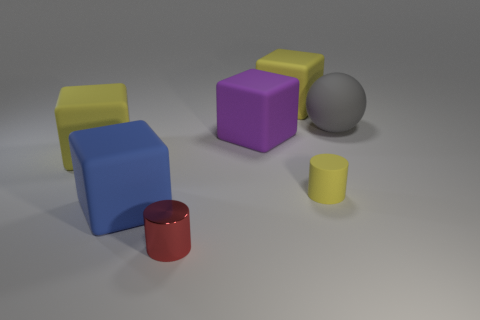Do the rubber cylinder and the matte block on the left side of the blue matte thing have the same color?
Provide a short and direct response. Yes. There is a large rubber cube on the left side of the big blue cube; is there a shiny thing behind it?
Your answer should be very brief. No. What size is the blue matte object?
Your response must be concise. Large. There is a thing that is both right of the blue rubber cube and in front of the small yellow rubber cylinder; what shape is it?
Your answer should be compact. Cylinder. What number of brown objects are either large spheres or rubber objects?
Keep it short and to the point. 0. Does the yellow matte block to the right of the big blue cube have the same size as the yellow matte cube that is in front of the purple matte object?
Offer a very short reply. Yes. What number of objects are big yellow objects or tiny matte blocks?
Give a very brief answer. 2. Are there any other large things that have the same shape as the big purple rubber thing?
Your answer should be compact. Yes. Is the number of cylinders less than the number of tiny gray blocks?
Offer a terse response. No. Is the shape of the purple object the same as the big blue rubber thing?
Provide a succinct answer. Yes. 